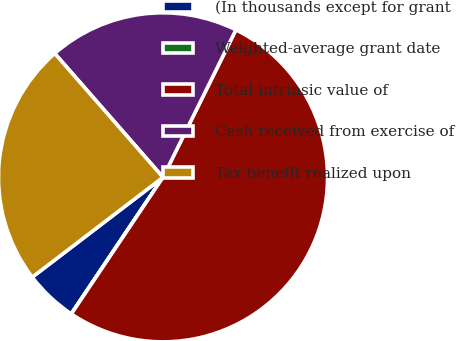<chart> <loc_0><loc_0><loc_500><loc_500><pie_chart><fcel>(In thousands except for grant<fcel>Weighted-average grant date<fcel>Total intrinsic value of<fcel>Cash received from exercise of<fcel>Tax benefit realized upon<nl><fcel>5.21%<fcel>0.01%<fcel>52.1%<fcel>18.74%<fcel>23.95%<nl></chart> 